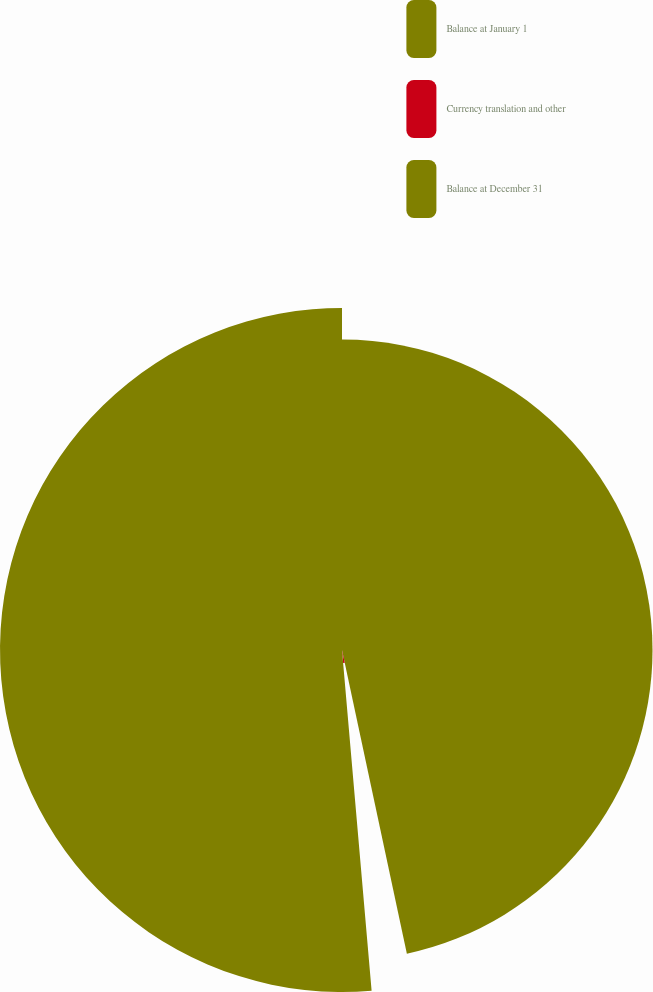<chart> <loc_0><loc_0><loc_500><loc_500><pie_chart><fcel>Balance at January 1<fcel>Currency translation and other<fcel>Balance at December 31<nl><fcel>46.65%<fcel>1.97%<fcel>51.38%<nl></chart> 